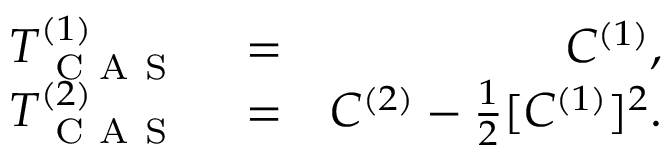<formula> <loc_0><loc_0><loc_500><loc_500>\begin{array} { r l r } { T _ { C A S } ^ { ( 1 ) } } & = } & { C ^ { ( 1 ) } , } \\ { T _ { C A S } ^ { ( 2 ) } } & = } & { C ^ { ( 2 ) } - \frac { 1 } { 2 } [ C ^ { ( 1 ) } ] ^ { 2 } . } \end{array}</formula> 